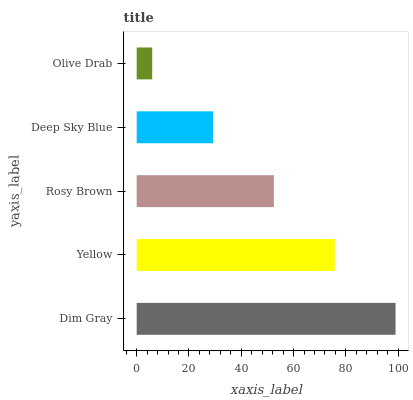Is Olive Drab the minimum?
Answer yes or no. Yes. Is Dim Gray the maximum?
Answer yes or no. Yes. Is Yellow the minimum?
Answer yes or no. No. Is Yellow the maximum?
Answer yes or no. No. Is Dim Gray greater than Yellow?
Answer yes or no. Yes. Is Yellow less than Dim Gray?
Answer yes or no. Yes. Is Yellow greater than Dim Gray?
Answer yes or no. No. Is Dim Gray less than Yellow?
Answer yes or no. No. Is Rosy Brown the high median?
Answer yes or no. Yes. Is Rosy Brown the low median?
Answer yes or no. Yes. Is Deep Sky Blue the high median?
Answer yes or no. No. Is Olive Drab the low median?
Answer yes or no. No. 